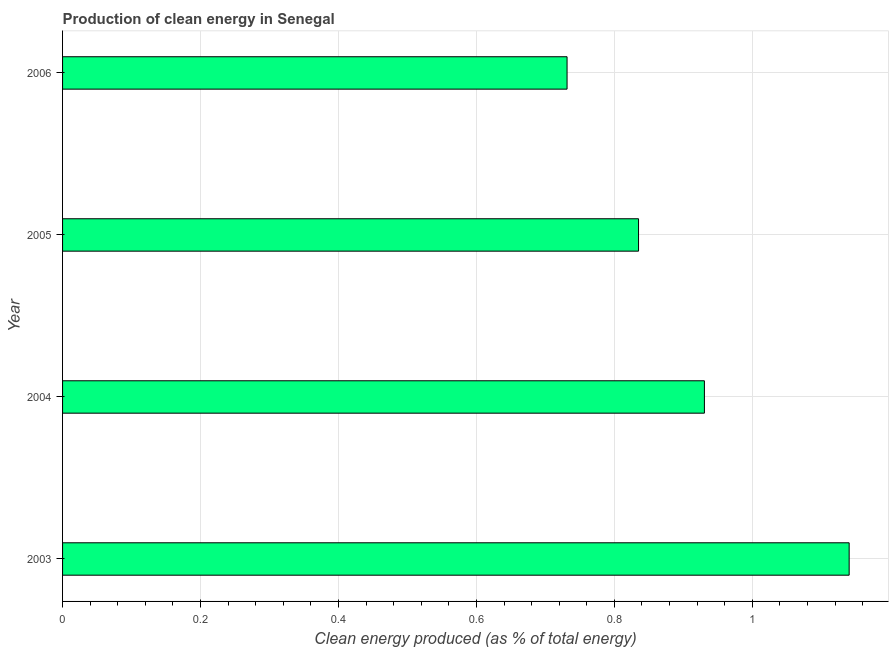Does the graph contain any zero values?
Provide a short and direct response. No. What is the title of the graph?
Keep it short and to the point. Production of clean energy in Senegal. What is the label or title of the X-axis?
Make the answer very short. Clean energy produced (as % of total energy). What is the label or title of the Y-axis?
Offer a very short reply. Year. What is the production of clean energy in 2006?
Offer a very short reply. 0.73. Across all years, what is the maximum production of clean energy?
Provide a short and direct response. 1.14. Across all years, what is the minimum production of clean energy?
Your answer should be compact. 0.73. What is the sum of the production of clean energy?
Make the answer very short. 3.64. What is the difference between the production of clean energy in 2003 and 2004?
Keep it short and to the point. 0.21. What is the average production of clean energy per year?
Ensure brevity in your answer.  0.91. What is the median production of clean energy?
Keep it short and to the point. 0.88. In how many years, is the production of clean energy greater than 1.08 %?
Your answer should be very brief. 1. Do a majority of the years between 2003 and 2006 (inclusive) have production of clean energy greater than 0.48 %?
Your answer should be very brief. Yes. What is the ratio of the production of clean energy in 2003 to that in 2005?
Ensure brevity in your answer.  1.37. Is the production of clean energy in 2004 less than that in 2006?
Provide a succinct answer. No. What is the difference between the highest and the second highest production of clean energy?
Provide a short and direct response. 0.21. Is the sum of the production of clean energy in 2004 and 2006 greater than the maximum production of clean energy across all years?
Provide a succinct answer. Yes. What is the difference between the highest and the lowest production of clean energy?
Ensure brevity in your answer.  0.41. In how many years, is the production of clean energy greater than the average production of clean energy taken over all years?
Offer a terse response. 2. How many bars are there?
Give a very brief answer. 4. Are the values on the major ticks of X-axis written in scientific E-notation?
Provide a short and direct response. No. What is the Clean energy produced (as % of total energy) in 2003?
Make the answer very short. 1.14. What is the Clean energy produced (as % of total energy) of 2004?
Make the answer very short. 0.93. What is the Clean energy produced (as % of total energy) in 2005?
Your answer should be compact. 0.84. What is the Clean energy produced (as % of total energy) in 2006?
Offer a terse response. 0.73. What is the difference between the Clean energy produced (as % of total energy) in 2003 and 2004?
Offer a very short reply. 0.21. What is the difference between the Clean energy produced (as % of total energy) in 2003 and 2005?
Your answer should be compact. 0.31. What is the difference between the Clean energy produced (as % of total energy) in 2003 and 2006?
Offer a very short reply. 0.41. What is the difference between the Clean energy produced (as % of total energy) in 2004 and 2005?
Ensure brevity in your answer.  0.1. What is the difference between the Clean energy produced (as % of total energy) in 2004 and 2006?
Ensure brevity in your answer.  0.2. What is the difference between the Clean energy produced (as % of total energy) in 2005 and 2006?
Ensure brevity in your answer.  0.1. What is the ratio of the Clean energy produced (as % of total energy) in 2003 to that in 2004?
Give a very brief answer. 1.23. What is the ratio of the Clean energy produced (as % of total energy) in 2003 to that in 2005?
Your response must be concise. 1.37. What is the ratio of the Clean energy produced (as % of total energy) in 2003 to that in 2006?
Keep it short and to the point. 1.56. What is the ratio of the Clean energy produced (as % of total energy) in 2004 to that in 2005?
Your response must be concise. 1.11. What is the ratio of the Clean energy produced (as % of total energy) in 2004 to that in 2006?
Ensure brevity in your answer.  1.27. What is the ratio of the Clean energy produced (as % of total energy) in 2005 to that in 2006?
Your answer should be compact. 1.14. 